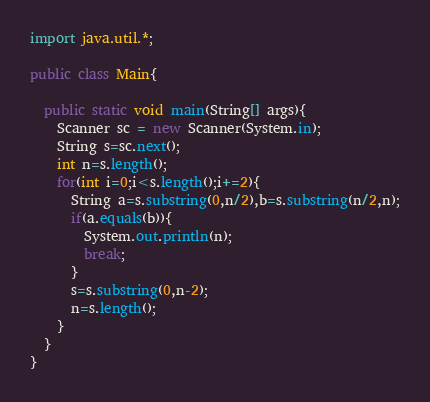<code> <loc_0><loc_0><loc_500><loc_500><_Java_>import java.util.*;

public class Main{
	
  public static void main(String[] args){
    Scanner sc = new Scanner(System.in);
  	String s=sc.next();
    int n=s.length();
    for(int i=0;i<s.length();i+=2){
      String a=s.substring(0,n/2),b=s.substring(n/2,n);
      if(a.equals(b)){
        System.out.println(n);
        break;
      }
      s=s.substring(0,n-2);
      n=s.length();
    }
  }
}
</code> 